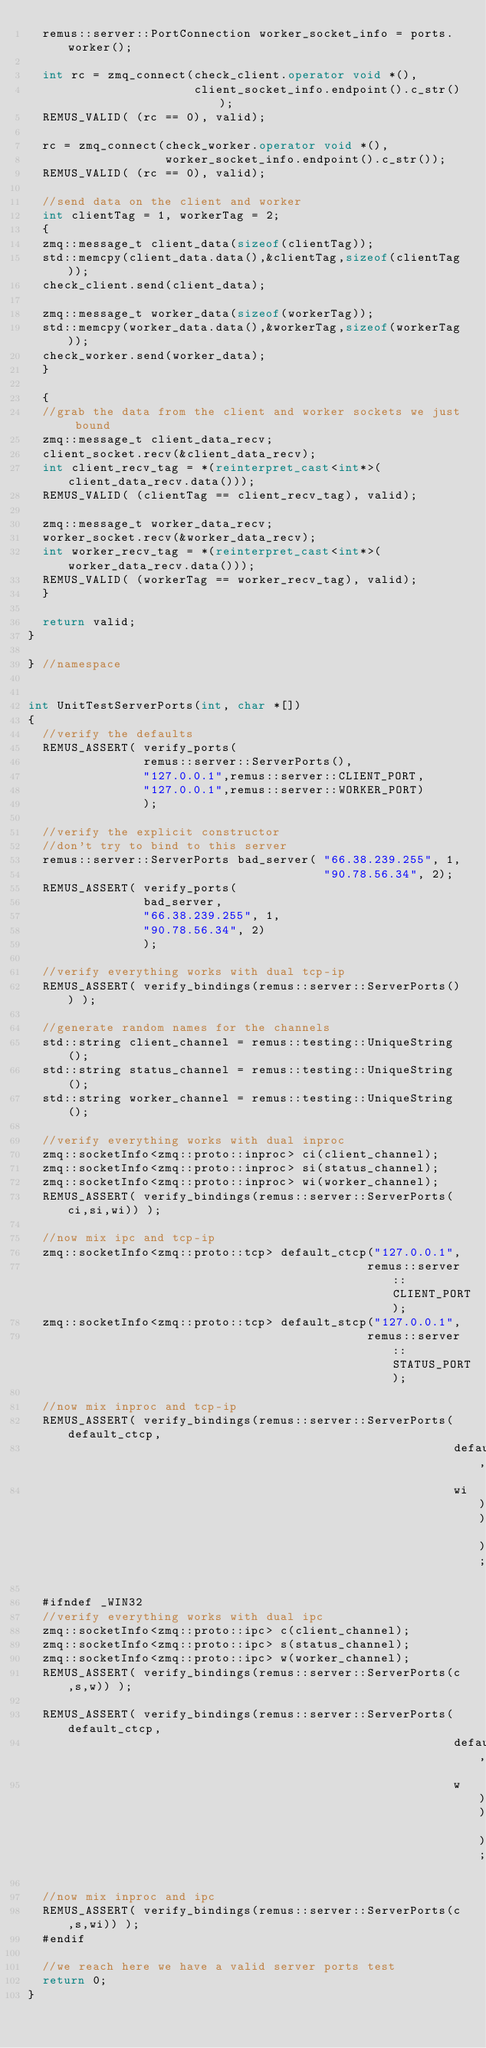Convert code to text. <code><loc_0><loc_0><loc_500><loc_500><_C++_>  remus::server::PortConnection worker_socket_info = ports.worker();

  int rc = zmq_connect(check_client.operator void *(),
                       client_socket_info.endpoint().c_str());
  REMUS_VALID( (rc == 0), valid);

  rc = zmq_connect(check_worker.operator void *(),
                   worker_socket_info.endpoint().c_str());
  REMUS_VALID( (rc == 0), valid);

  //send data on the client and worker
  int clientTag = 1, workerTag = 2;
  {
  zmq::message_t client_data(sizeof(clientTag));
  std::memcpy(client_data.data(),&clientTag,sizeof(clientTag));
  check_client.send(client_data);

  zmq::message_t worker_data(sizeof(workerTag));
  std::memcpy(worker_data.data(),&workerTag,sizeof(workerTag));
  check_worker.send(worker_data);
  }

  {
  //grab the data from the client and worker sockets we just bound
  zmq::message_t client_data_recv;
  client_socket.recv(&client_data_recv);
  int client_recv_tag = *(reinterpret_cast<int*>(client_data_recv.data()));
  REMUS_VALID( (clientTag == client_recv_tag), valid);

  zmq::message_t worker_data_recv;
  worker_socket.recv(&worker_data_recv);
  int worker_recv_tag = *(reinterpret_cast<int*>(worker_data_recv.data()));
  REMUS_VALID( (workerTag == worker_recv_tag), valid);
  }

  return valid;
}

} //namespace


int UnitTestServerPorts(int, char *[])
{
  //verify the defaults
  REMUS_ASSERT( verify_ports(
                remus::server::ServerPorts(),
                "127.0.0.1",remus::server::CLIENT_PORT,
                "127.0.0.1",remus::server::WORKER_PORT)
                );

  //verify the explicit constructor
  //don't try to bind to this server
  remus::server::ServerPorts bad_server( "66.38.239.255", 1,
                                         "90.78.56.34", 2);
  REMUS_ASSERT( verify_ports(
                bad_server,
                "66.38.239.255", 1,
                "90.78.56.34", 2)
                );

  //verify everything works with dual tcp-ip
  REMUS_ASSERT( verify_bindings(remus::server::ServerPorts()) );

  //generate random names for the channels
  std::string client_channel = remus::testing::UniqueString();
  std::string status_channel = remus::testing::UniqueString();
  std::string worker_channel = remus::testing::UniqueString();

  //verify everything works with dual inproc
  zmq::socketInfo<zmq::proto::inproc> ci(client_channel);
  zmq::socketInfo<zmq::proto::inproc> si(status_channel);
  zmq::socketInfo<zmq::proto::inproc> wi(worker_channel);
  REMUS_ASSERT( verify_bindings(remus::server::ServerPorts(ci,si,wi)) );

  //now mix ipc and tcp-ip
  zmq::socketInfo<zmq::proto::tcp> default_ctcp("127.0.0.1",
                                               remus::server::CLIENT_PORT);
  zmq::socketInfo<zmq::proto::tcp> default_stcp("127.0.0.1",
                                               remus::server::STATUS_PORT);

  //now mix inproc and tcp-ip
  REMUS_ASSERT( verify_bindings(remus::server::ServerPorts(default_ctcp,
                                                           default_stcp,
                                                           wi)) );

  #ifndef _WIN32
  //verify everything works with dual ipc
  zmq::socketInfo<zmq::proto::ipc> c(client_channel);
  zmq::socketInfo<zmq::proto::ipc> s(status_channel);
  zmq::socketInfo<zmq::proto::ipc> w(worker_channel);
  REMUS_ASSERT( verify_bindings(remus::server::ServerPorts(c,s,w)) );

  REMUS_ASSERT( verify_bindings(remus::server::ServerPorts(default_ctcp,
                                                           default_stcp,
                                                           w)) );

  //now mix inproc and ipc
  REMUS_ASSERT( verify_bindings(remus::server::ServerPorts(c,s,wi)) );
  #endif

  //we reach here we have a valid server ports test
  return 0;
}
</code> 